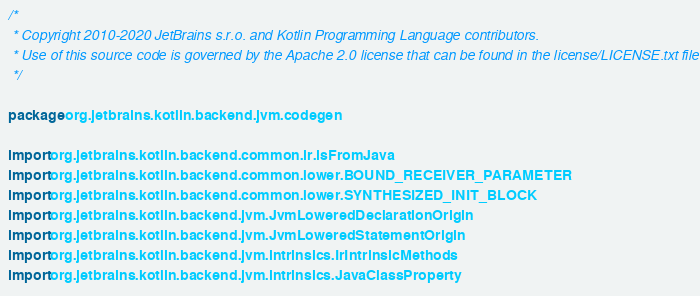Convert code to text. <code><loc_0><loc_0><loc_500><loc_500><_Kotlin_>/*
 * Copyright 2010-2020 JetBrains s.r.o. and Kotlin Programming Language contributors.
 * Use of this source code is governed by the Apache 2.0 license that can be found in the license/LICENSE.txt file.
 */

package org.jetbrains.kotlin.backend.jvm.codegen

import org.jetbrains.kotlin.backend.common.ir.isFromJava
import org.jetbrains.kotlin.backend.common.lower.BOUND_RECEIVER_PARAMETER
import org.jetbrains.kotlin.backend.common.lower.SYNTHESIZED_INIT_BLOCK
import org.jetbrains.kotlin.backend.jvm.JvmLoweredDeclarationOrigin
import org.jetbrains.kotlin.backend.jvm.JvmLoweredStatementOrigin
import org.jetbrains.kotlin.backend.jvm.intrinsics.IrIntrinsicMethods
import org.jetbrains.kotlin.backend.jvm.intrinsics.JavaClassProperty</code> 